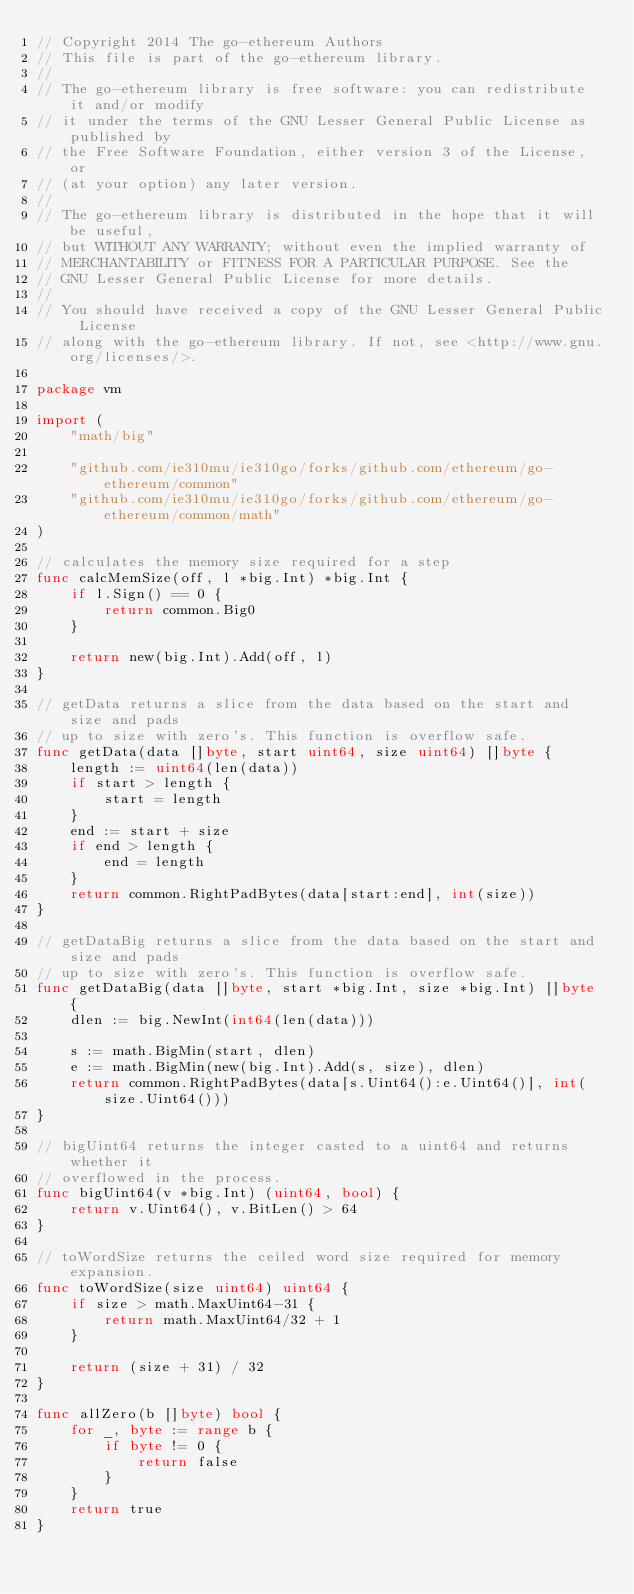<code> <loc_0><loc_0><loc_500><loc_500><_Go_>// Copyright 2014 The go-ethereum Authors
// This file is part of the go-ethereum library.
//
// The go-ethereum library is free software: you can redistribute it and/or modify
// it under the terms of the GNU Lesser General Public License as published by
// the Free Software Foundation, either version 3 of the License, or
// (at your option) any later version.
//
// The go-ethereum library is distributed in the hope that it will be useful,
// but WITHOUT ANY WARRANTY; without even the implied warranty of
// MERCHANTABILITY or FITNESS FOR A PARTICULAR PURPOSE. See the
// GNU Lesser General Public License for more details.
//
// You should have received a copy of the GNU Lesser General Public License
// along with the go-ethereum library. If not, see <http://www.gnu.org/licenses/>.

package vm

import (
	"math/big"

	"github.com/ie310mu/ie310go/forks/github.com/ethereum/go-ethereum/common"
	"github.com/ie310mu/ie310go/forks/github.com/ethereum/go-ethereum/common/math"
)

// calculates the memory size required for a step
func calcMemSize(off, l *big.Int) *big.Int {
	if l.Sign() == 0 {
		return common.Big0
	}

	return new(big.Int).Add(off, l)
}

// getData returns a slice from the data based on the start and size and pads
// up to size with zero's. This function is overflow safe.
func getData(data []byte, start uint64, size uint64) []byte {
	length := uint64(len(data))
	if start > length {
		start = length
	}
	end := start + size
	if end > length {
		end = length
	}
	return common.RightPadBytes(data[start:end], int(size))
}

// getDataBig returns a slice from the data based on the start and size and pads
// up to size with zero's. This function is overflow safe.
func getDataBig(data []byte, start *big.Int, size *big.Int) []byte {
	dlen := big.NewInt(int64(len(data)))

	s := math.BigMin(start, dlen)
	e := math.BigMin(new(big.Int).Add(s, size), dlen)
	return common.RightPadBytes(data[s.Uint64():e.Uint64()], int(size.Uint64()))
}

// bigUint64 returns the integer casted to a uint64 and returns whether it
// overflowed in the process.
func bigUint64(v *big.Int) (uint64, bool) {
	return v.Uint64(), v.BitLen() > 64
}

// toWordSize returns the ceiled word size required for memory expansion.
func toWordSize(size uint64) uint64 {
	if size > math.MaxUint64-31 {
		return math.MaxUint64/32 + 1
	}

	return (size + 31) / 32
}

func allZero(b []byte) bool {
	for _, byte := range b {
		if byte != 0 {
			return false
		}
	}
	return true
}
</code> 